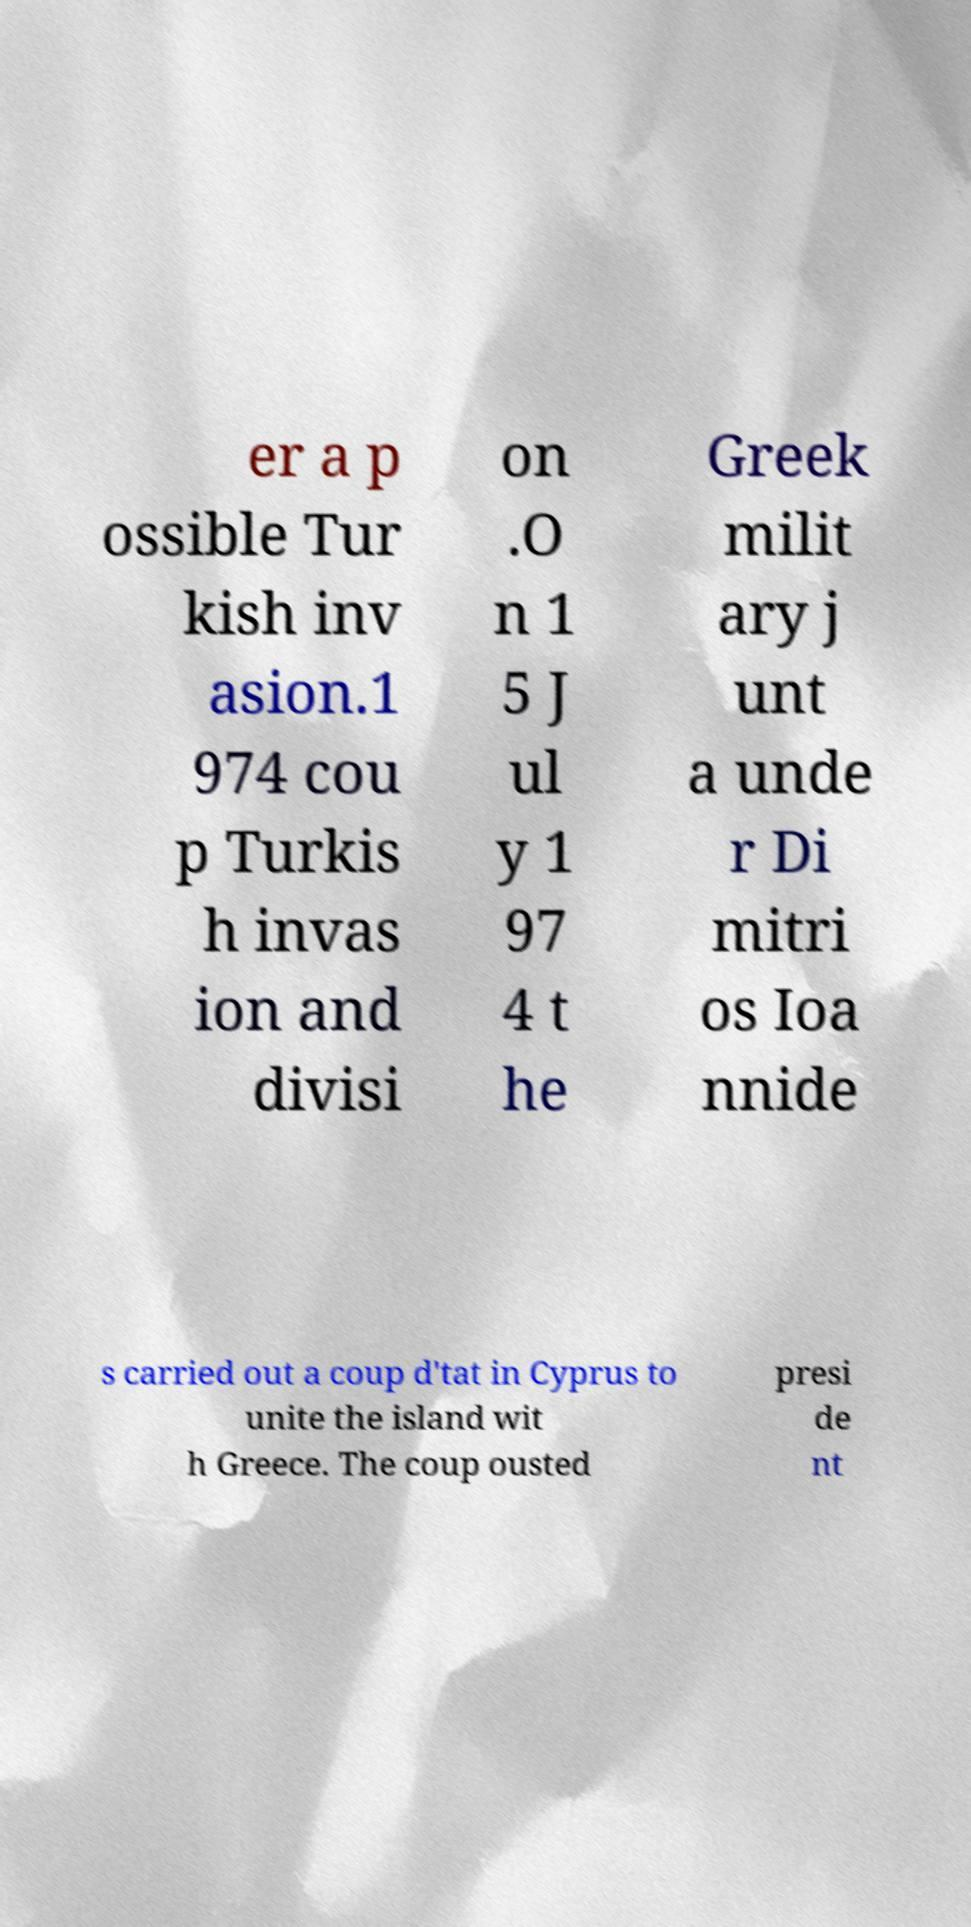Could you assist in decoding the text presented in this image and type it out clearly? er a p ossible Tur kish inv asion.1 974 cou p Turkis h invas ion and divisi on .O n 1 5 J ul y 1 97 4 t he Greek milit ary j unt a unde r Di mitri os Ioa nnide s carried out a coup d'tat in Cyprus to unite the island wit h Greece. The coup ousted presi de nt 